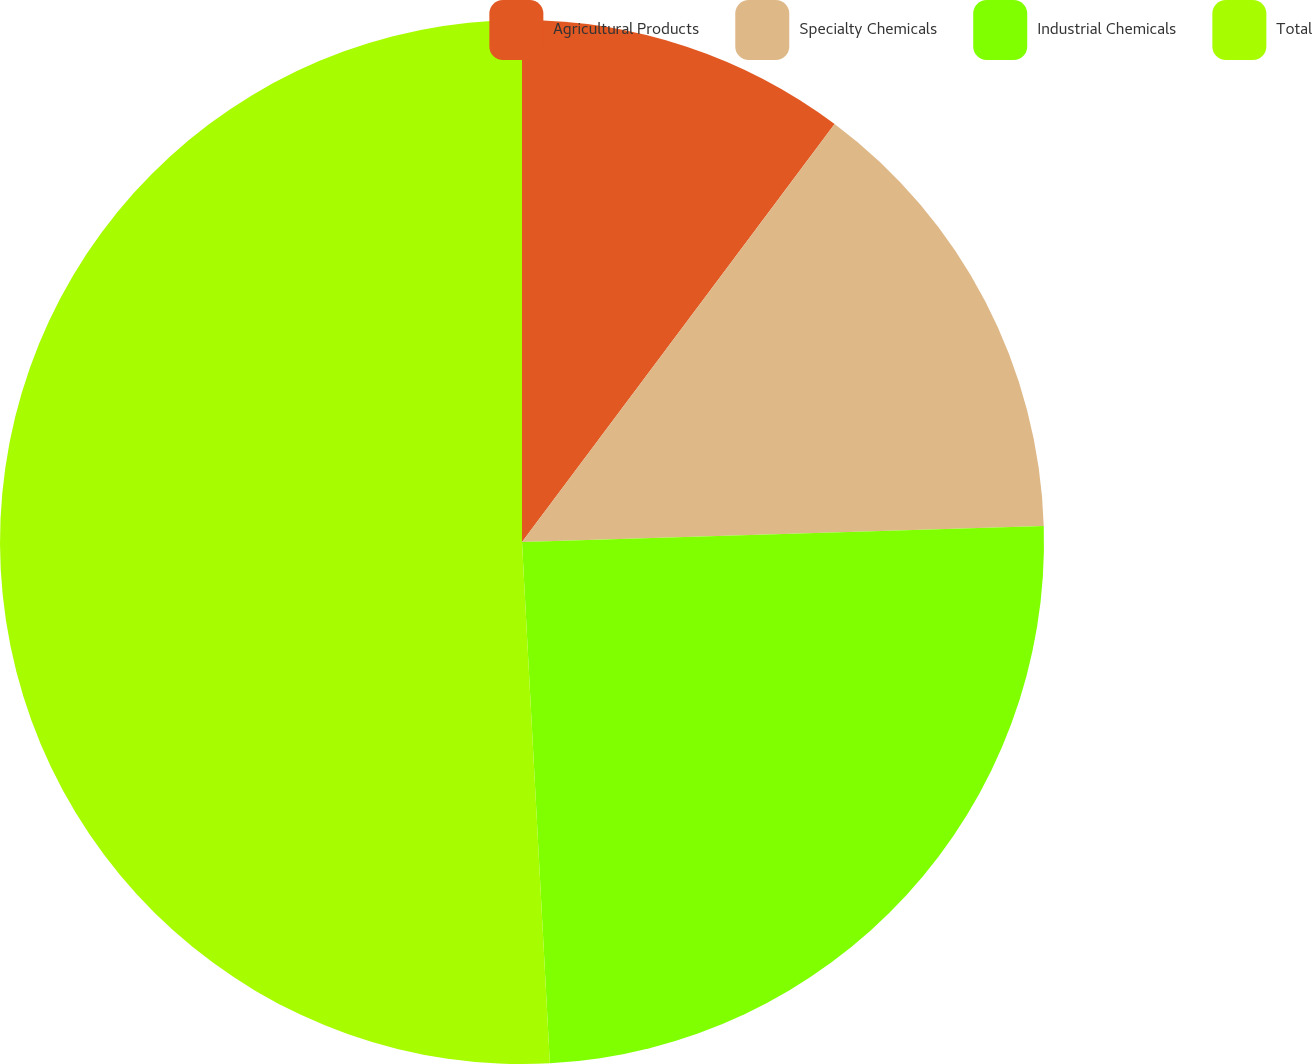Convert chart. <chart><loc_0><loc_0><loc_500><loc_500><pie_chart><fcel>Agricultural Products<fcel>Specialty Chemicals<fcel>Industrial Chemicals<fcel>Total<nl><fcel>10.22%<fcel>14.29%<fcel>24.64%<fcel>50.85%<nl></chart> 